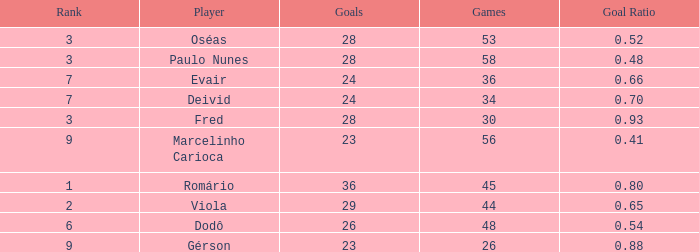How many goals have a goal ration less than 0.8 with 56 games? 1.0. 